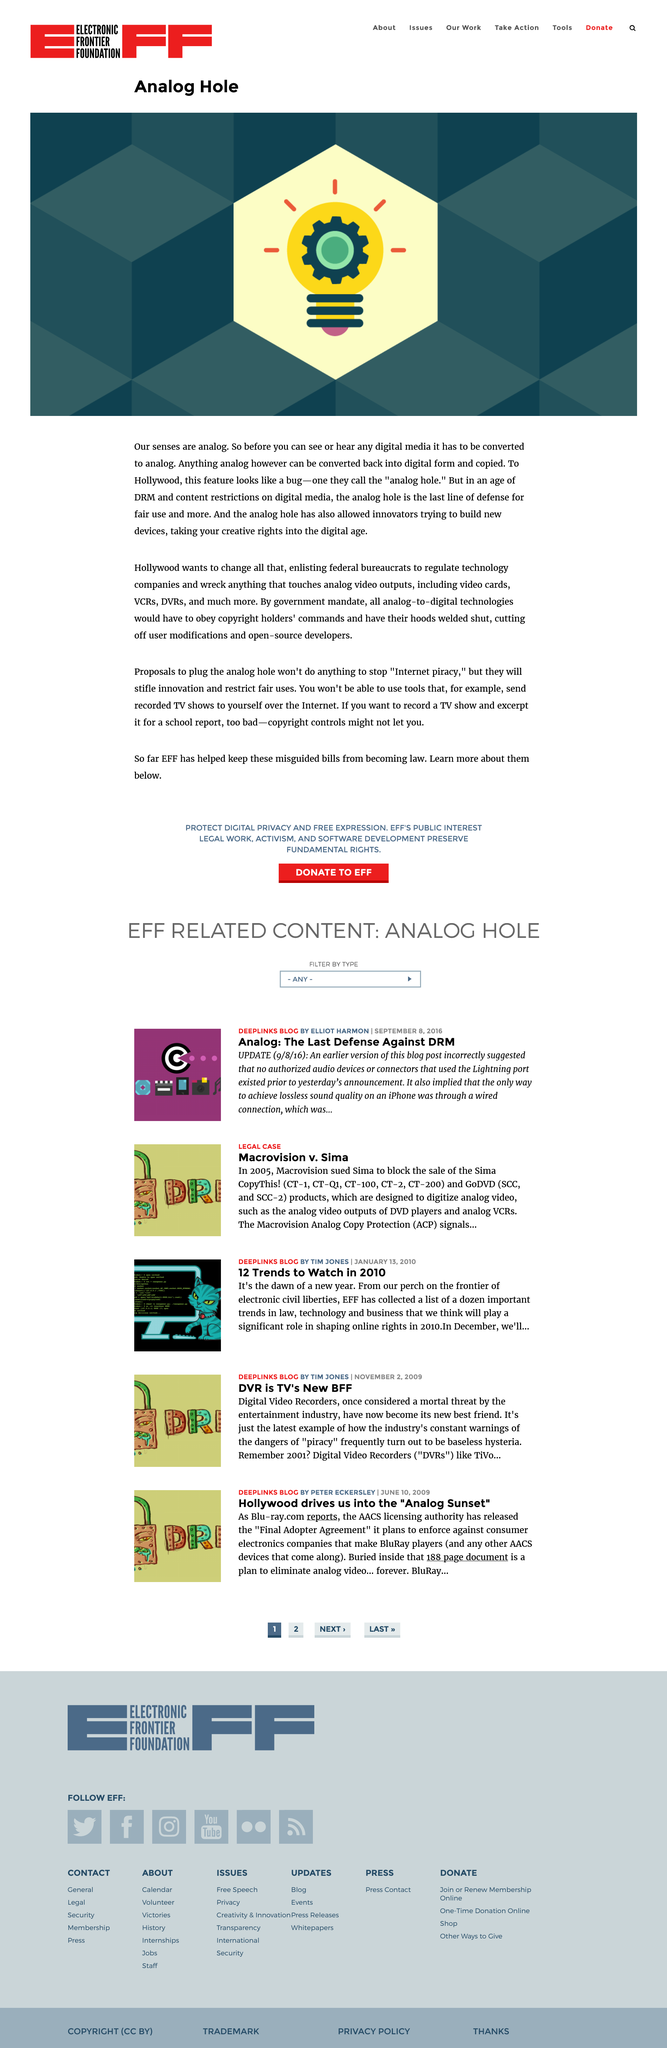Give some essential details in this illustration. The title of the page is "Analog Hole...". The image depicts a light bulb. According to the article, "Analog Hole" states that all analog-to-digital technologies would have to obey the copyright holder's commands. 